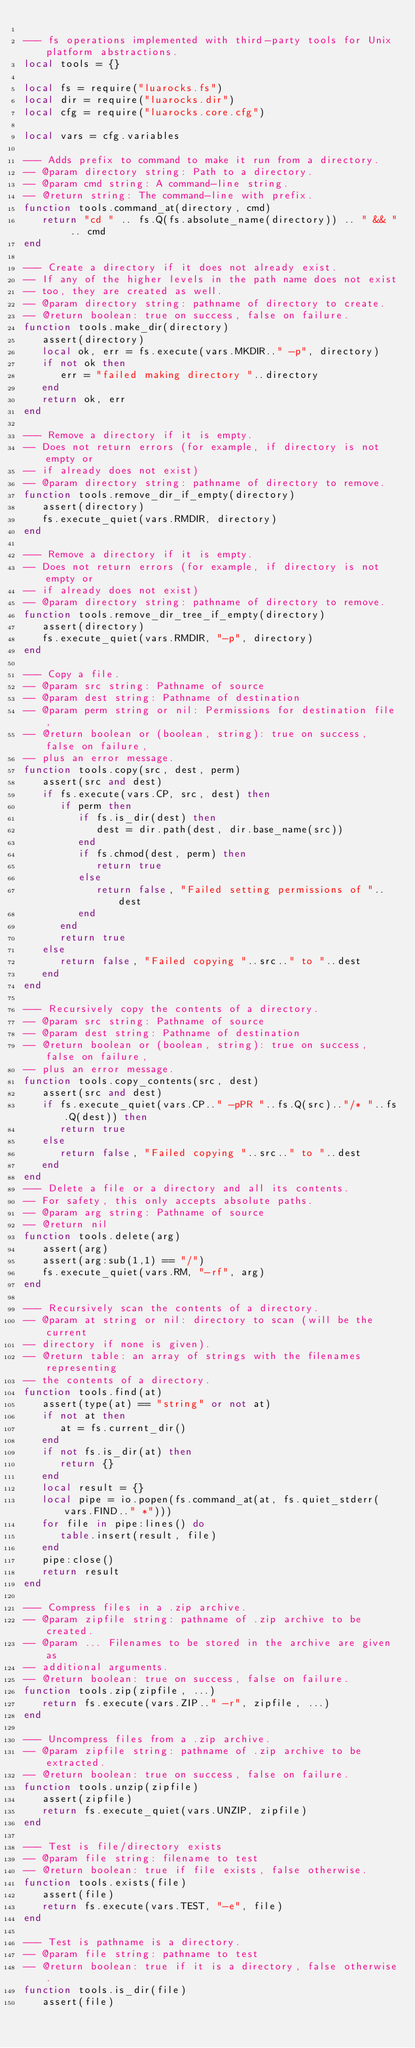<code> <loc_0><loc_0><loc_500><loc_500><_Lua_>
--- fs operations implemented with third-party tools for Unix platform abstractions.
local tools = {}

local fs = require("luarocks.fs")
local dir = require("luarocks.dir")
local cfg = require("luarocks.core.cfg")

local vars = cfg.variables

--- Adds prefix to command to make it run from a directory.
-- @param directory string: Path to a directory.
-- @param cmd string: A command-line string.
-- @return string: The command-line with prefix.
function tools.command_at(directory, cmd)
   return "cd " .. fs.Q(fs.absolute_name(directory)) .. " && " .. cmd
end

--- Create a directory if it does not already exist.
-- If any of the higher levels in the path name does not exist
-- too, they are created as well.
-- @param directory string: pathname of directory to create.
-- @return boolean: true on success, false on failure.
function tools.make_dir(directory)
   assert(directory)
   local ok, err = fs.execute(vars.MKDIR.." -p", directory)
   if not ok then
      err = "failed making directory "..directory
   end
   return ok, err
end

--- Remove a directory if it is empty.
-- Does not return errors (for example, if directory is not empty or
-- if already does not exist)
-- @param directory string: pathname of directory to remove.
function tools.remove_dir_if_empty(directory)
   assert(directory)
   fs.execute_quiet(vars.RMDIR, directory)
end

--- Remove a directory if it is empty.
-- Does not return errors (for example, if directory is not empty or
-- if already does not exist)
-- @param directory string: pathname of directory to remove.
function tools.remove_dir_tree_if_empty(directory)
   assert(directory)
   fs.execute_quiet(vars.RMDIR, "-p", directory)
end

--- Copy a file.
-- @param src string: Pathname of source
-- @param dest string: Pathname of destination
-- @param perm string or nil: Permissions for destination file,
-- @return boolean or (boolean, string): true on success, false on failure,
-- plus an error message.
function tools.copy(src, dest, perm)
   assert(src and dest)
   if fs.execute(vars.CP, src, dest) then
      if perm then
         if fs.is_dir(dest) then
            dest = dir.path(dest, dir.base_name(src))
         end
         if fs.chmod(dest, perm) then
            return true
         else
            return false, "Failed setting permissions of "..dest
         end
      end
      return true
   else
      return false, "Failed copying "..src.." to "..dest
   end
end

--- Recursively copy the contents of a directory.
-- @param src string: Pathname of source
-- @param dest string: Pathname of destination
-- @return boolean or (boolean, string): true on success, false on failure,
-- plus an error message.
function tools.copy_contents(src, dest)
   assert(src and dest)
   if fs.execute_quiet(vars.CP.." -pPR "..fs.Q(src).."/* "..fs.Q(dest)) then
      return true
   else
      return false, "Failed copying "..src.." to "..dest
   end
end
--- Delete a file or a directory and all its contents.
-- For safety, this only accepts absolute paths.
-- @param arg string: Pathname of source
-- @return nil
function tools.delete(arg)
   assert(arg)
   assert(arg:sub(1,1) == "/")
   fs.execute_quiet(vars.RM, "-rf", arg)
end

--- Recursively scan the contents of a directory.
-- @param at string or nil: directory to scan (will be the current
-- directory if none is given).
-- @return table: an array of strings with the filenames representing
-- the contents of a directory.
function tools.find(at)
   assert(type(at) == "string" or not at)
   if not at then
      at = fs.current_dir()
   end
   if not fs.is_dir(at) then
      return {}
   end
   local result = {}
   local pipe = io.popen(fs.command_at(at, fs.quiet_stderr(vars.FIND.." *")))
   for file in pipe:lines() do
      table.insert(result, file)
   end
   pipe:close()
   return result
end

--- Compress files in a .zip archive.
-- @param zipfile string: pathname of .zip archive to be created.
-- @param ... Filenames to be stored in the archive are given as
-- additional arguments.
-- @return boolean: true on success, false on failure.
function tools.zip(zipfile, ...)
   return fs.execute(vars.ZIP.." -r", zipfile, ...)
end

--- Uncompress files from a .zip archive.
-- @param zipfile string: pathname of .zip archive to be extracted.
-- @return boolean: true on success, false on failure.
function tools.unzip(zipfile)
   assert(zipfile)
   return fs.execute_quiet(vars.UNZIP, zipfile)
end

--- Test is file/directory exists
-- @param file string: filename to test
-- @return boolean: true if file exists, false otherwise.
function tools.exists(file)
   assert(file)
   return fs.execute(vars.TEST, "-e", file)
end

--- Test is pathname is a directory.
-- @param file string: pathname to test
-- @return boolean: true if it is a directory, false otherwise.
function tools.is_dir(file)
   assert(file)</code> 